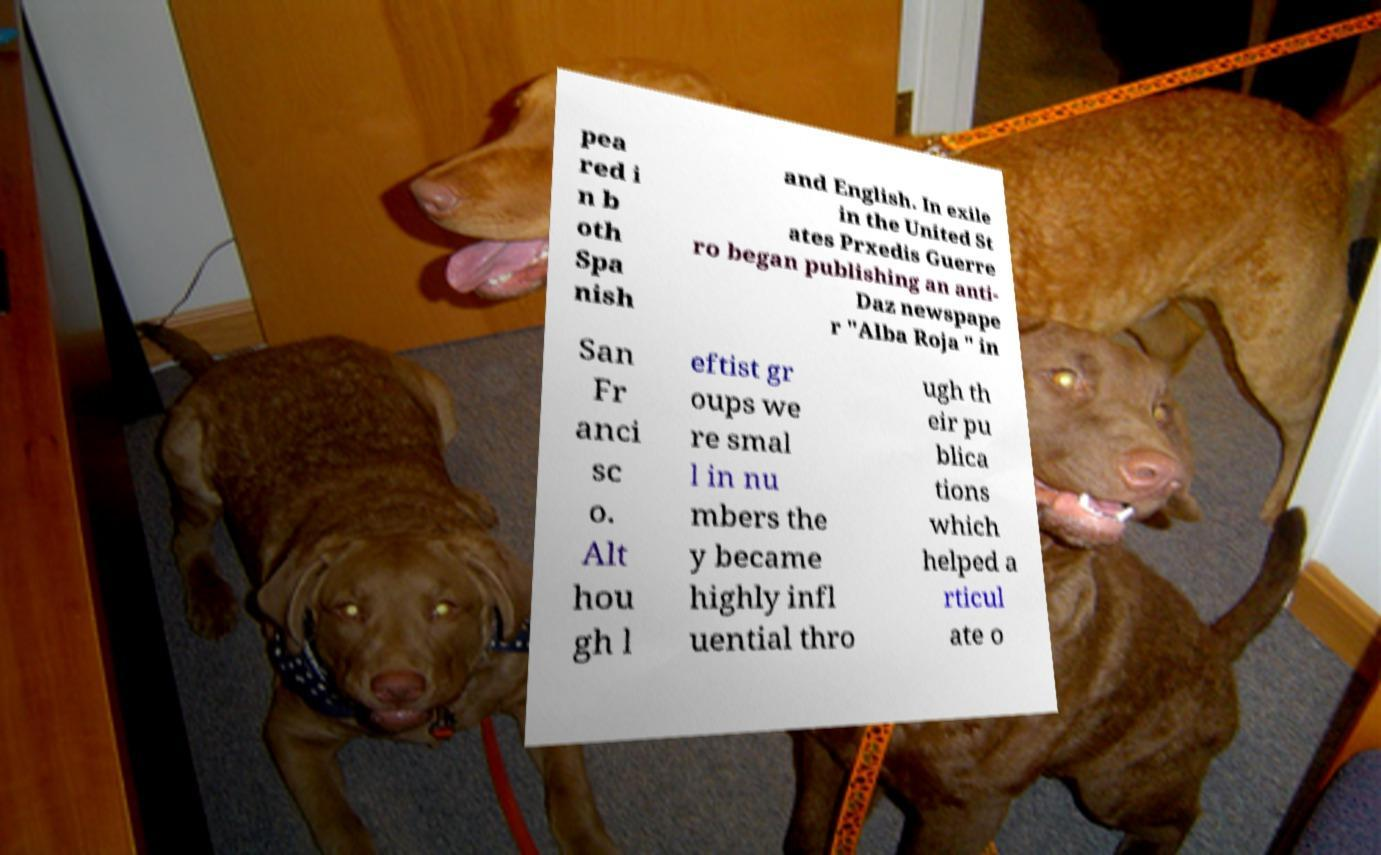There's text embedded in this image that I need extracted. Can you transcribe it verbatim? pea red i n b oth Spa nish and English. In exile in the United St ates Prxedis Guerre ro began publishing an anti- Daz newspape r "Alba Roja " in San Fr anci sc o. Alt hou gh l eftist gr oups we re smal l in nu mbers the y became highly infl uential thro ugh th eir pu blica tions which helped a rticul ate o 